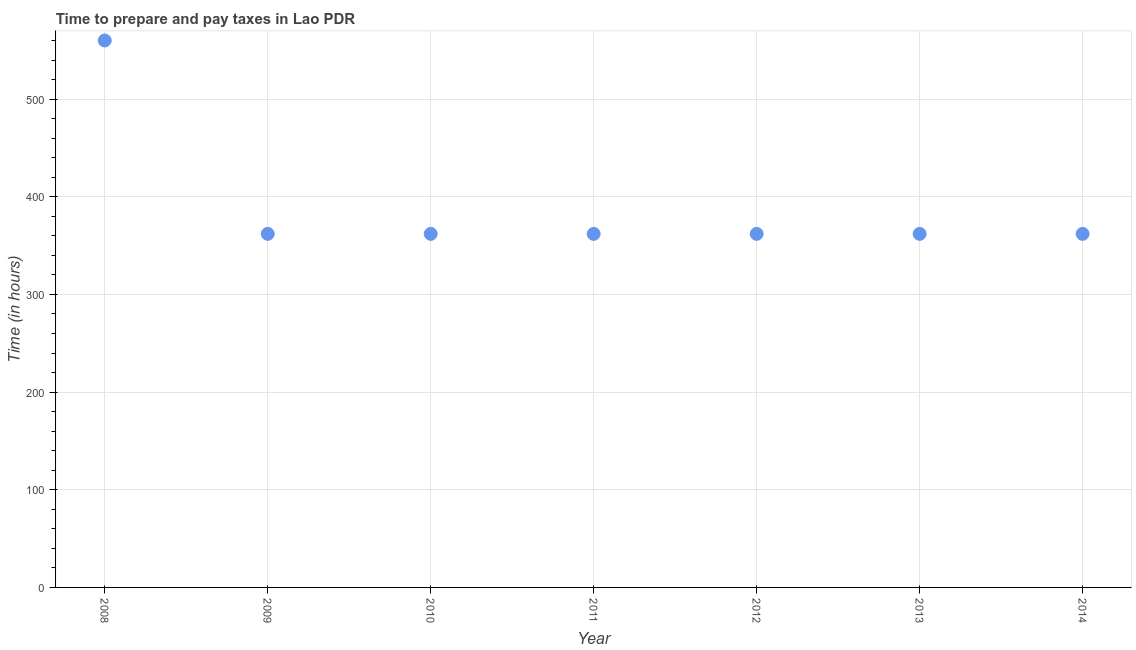What is the time to prepare and pay taxes in 2014?
Keep it short and to the point. 362. Across all years, what is the maximum time to prepare and pay taxes?
Offer a very short reply. 560. Across all years, what is the minimum time to prepare and pay taxes?
Offer a very short reply. 362. In which year was the time to prepare and pay taxes maximum?
Offer a very short reply. 2008. What is the sum of the time to prepare and pay taxes?
Your answer should be very brief. 2732. What is the difference between the time to prepare and pay taxes in 2008 and 2013?
Offer a very short reply. 198. What is the average time to prepare and pay taxes per year?
Ensure brevity in your answer.  390.29. What is the median time to prepare and pay taxes?
Offer a terse response. 362. What is the ratio of the time to prepare and pay taxes in 2013 to that in 2014?
Give a very brief answer. 1. Is the time to prepare and pay taxes in 2009 less than that in 2013?
Provide a short and direct response. No. Is the difference between the time to prepare and pay taxes in 2009 and 2011 greater than the difference between any two years?
Ensure brevity in your answer.  No. What is the difference between the highest and the second highest time to prepare and pay taxes?
Make the answer very short. 198. What is the difference between the highest and the lowest time to prepare and pay taxes?
Give a very brief answer. 198. What is the difference between two consecutive major ticks on the Y-axis?
Your response must be concise. 100. Does the graph contain any zero values?
Your answer should be very brief. No. Does the graph contain grids?
Your response must be concise. Yes. What is the title of the graph?
Provide a short and direct response. Time to prepare and pay taxes in Lao PDR. What is the label or title of the X-axis?
Offer a very short reply. Year. What is the label or title of the Y-axis?
Provide a succinct answer. Time (in hours). What is the Time (in hours) in 2008?
Your response must be concise. 560. What is the Time (in hours) in 2009?
Provide a short and direct response. 362. What is the Time (in hours) in 2010?
Provide a short and direct response. 362. What is the Time (in hours) in 2011?
Give a very brief answer. 362. What is the Time (in hours) in 2012?
Keep it short and to the point. 362. What is the Time (in hours) in 2013?
Provide a short and direct response. 362. What is the Time (in hours) in 2014?
Your answer should be very brief. 362. What is the difference between the Time (in hours) in 2008 and 2009?
Offer a very short reply. 198. What is the difference between the Time (in hours) in 2008 and 2010?
Your answer should be compact. 198. What is the difference between the Time (in hours) in 2008 and 2011?
Your response must be concise. 198. What is the difference between the Time (in hours) in 2008 and 2012?
Offer a terse response. 198. What is the difference between the Time (in hours) in 2008 and 2013?
Keep it short and to the point. 198. What is the difference between the Time (in hours) in 2008 and 2014?
Give a very brief answer. 198. What is the difference between the Time (in hours) in 2010 and 2011?
Offer a terse response. 0. What is the difference between the Time (in hours) in 2010 and 2013?
Give a very brief answer. 0. What is the difference between the Time (in hours) in 2010 and 2014?
Your answer should be compact. 0. What is the difference between the Time (in hours) in 2011 and 2012?
Offer a very short reply. 0. What is the difference between the Time (in hours) in 2011 and 2013?
Your answer should be compact. 0. What is the difference between the Time (in hours) in 2012 and 2014?
Your response must be concise. 0. What is the difference between the Time (in hours) in 2013 and 2014?
Ensure brevity in your answer.  0. What is the ratio of the Time (in hours) in 2008 to that in 2009?
Offer a very short reply. 1.55. What is the ratio of the Time (in hours) in 2008 to that in 2010?
Keep it short and to the point. 1.55. What is the ratio of the Time (in hours) in 2008 to that in 2011?
Ensure brevity in your answer.  1.55. What is the ratio of the Time (in hours) in 2008 to that in 2012?
Ensure brevity in your answer.  1.55. What is the ratio of the Time (in hours) in 2008 to that in 2013?
Provide a short and direct response. 1.55. What is the ratio of the Time (in hours) in 2008 to that in 2014?
Your answer should be compact. 1.55. What is the ratio of the Time (in hours) in 2009 to that in 2011?
Your answer should be very brief. 1. What is the ratio of the Time (in hours) in 2009 to that in 2012?
Give a very brief answer. 1. What is the ratio of the Time (in hours) in 2009 to that in 2013?
Your answer should be very brief. 1. What is the ratio of the Time (in hours) in 2010 to that in 2014?
Give a very brief answer. 1. What is the ratio of the Time (in hours) in 2011 to that in 2013?
Provide a succinct answer. 1. What is the ratio of the Time (in hours) in 2013 to that in 2014?
Keep it short and to the point. 1. 